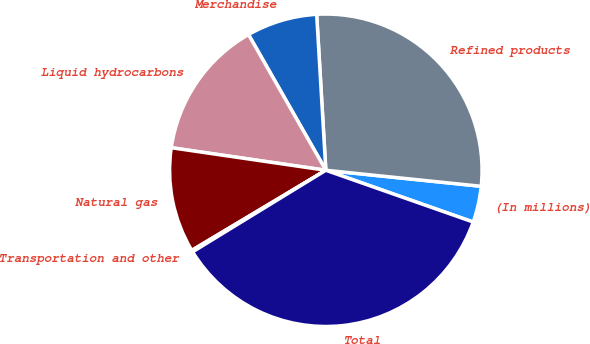Convert chart. <chart><loc_0><loc_0><loc_500><loc_500><pie_chart><fcel>(In millions)<fcel>Refined products<fcel>Merchandise<fcel>Liquid hydrocarbons<fcel>Natural gas<fcel>Transportation and other<fcel>Total<nl><fcel>3.74%<fcel>27.57%<fcel>7.31%<fcel>14.45%<fcel>10.88%<fcel>0.17%<fcel>35.88%<nl></chart> 